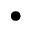Convert formula to latex. <formula><loc_0><loc_0><loc_500><loc_500>\bullet</formula> 